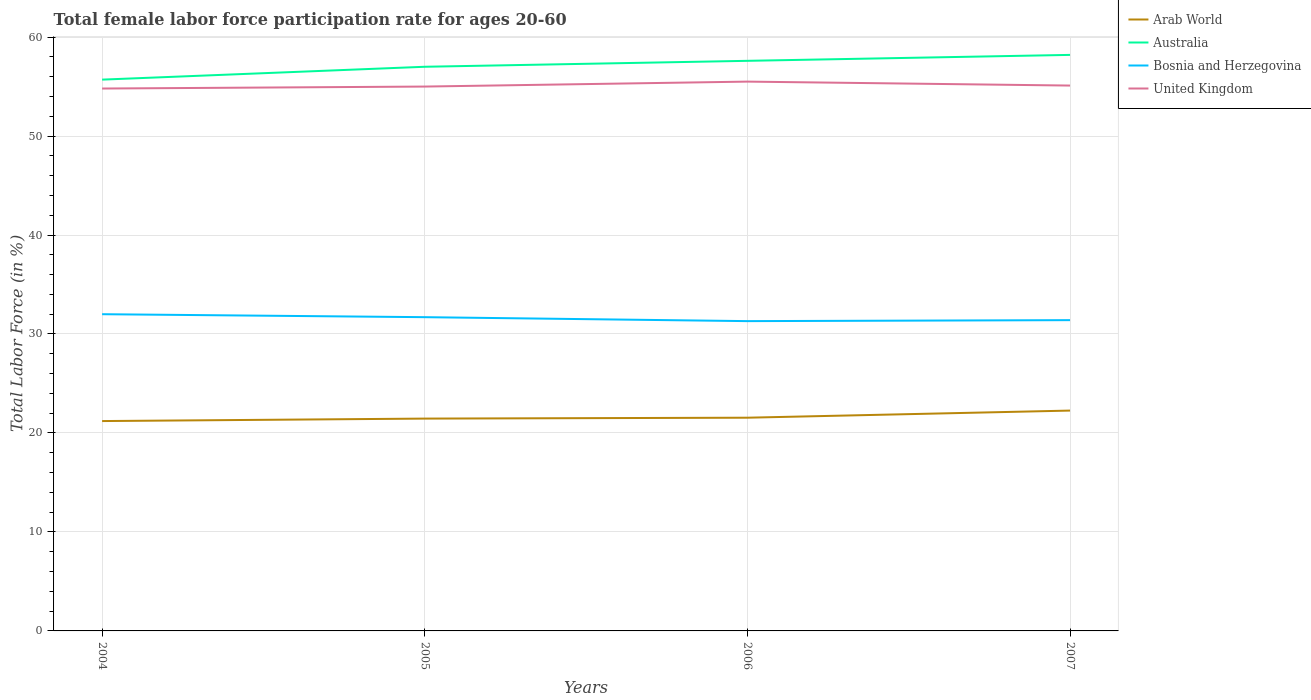How many different coloured lines are there?
Give a very brief answer. 4. Does the line corresponding to Australia intersect with the line corresponding to Bosnia and Herzegovina?
Keep it short and to the point. No. Across all years, what is the maximum female labor force participation rate in United Kingdom?
Your answer should be very brief. 54.8. What is the total female labor force participation rate in Arab World in the graph?
Your answer should be compact. -0.09. What is the difference between the highest and the lowest female labor force participation rate in Bosnia and Herzegovina?
Provide a short and direct response. 2. Is the female labor force participation rate in Australia strictly greater than the female labor force participation rate in Bosnia and Herzegovina over the years?
Provide a short and direct response. No. How many years are there in the graph?
Offer a terse response. 4. Does the graph contain grids?
Give a very brief answer. Yes. Where does the legend appear in the graph?
Ensure brevity in your answer.  Top right. How many legend labels are there?
Make the answer very short. 4. What is the title of the graph?
Your answer should be very brief. Total female labor force participation rate for ages 20-60. Does "Belgium" appear as one of the legend labels in the graph?
Your response must be concise. No. What is the label or title of the X-axis?
Your answer should be compact. Years. What is the label or title of the Y-axis?
Your answer should be very brief. Total Labor Force (in %). What is the Total Labor Force (in %) in Arab World in 2004?
Your response must be concise. 21.2. What is the Total Labor Force (in %) in Australia in 2004?
Ensure brevity in your answer.  55.7. What is the Total Labor Force (in %) of United Kingdom in 2004?
Keep it short and to the point. 54.8. What is the Total Labor Force (in %) in Arab World in 2005?
Offer a terse response. 21.45. What is the Total Labor Force (in %) in Australia in 2005?
Give a very brief answer. 57. What is the Total Labor Force (in %) in Bosnia and Herzegovina in 2005?
Offer a terse response. 31.7. What is the Total Labor Force (in %) of United Kingdom in 2005?
Keep it short and to the point. 55. What is the Total Labor Force (in %) of Arab World in 2006?
Offer a very short reply. 21.54. What is the Total Labor Force (in %) in Australia in 2006?
Keep it short and to the point. 57.6. What is the Total Labor Force (in %) of Bosnia and Herzegovina in 2006?
Provide a short and direct response. 31.3. What is the Total Labor Force (in %) in United Kingdom in 2006?
Your response must be concise. 55.5. What is the Total Labor Force (in %) in Arab World in 2007?
Provide a short and direct response. 22.26. What is the Total Labor Force (in %) in Australia in 2007?
Give a very brief answer. 58.2. What is the Total Labor Force (in %) in Bosnia and Herzegovina in 2007?
Give a very brief answer. 31.4. What is the Total Labor Force (in %) in United Kingdom in 2007?
Give a very brief answer. 55.1. Across all years, what is the maximum Total Labor Force (in %) of Arab World?
Keep it short and to the point. 22.26. Across all years, what is the maximum Total Labor Force (in %) in Australia?
Give a very brief answer. 58.2. Across all years, what is the maximum Total Labor Force (in %) in United Kingdom?
Provide a succinct answer. 55.5. Across all years, what is the minimum Total Labor Force (in %) of Arab World?
Your answer should be compact. 21.2. Across all years, what is the minimum Total Labor Force (in %) of Australia?
Make the answer very short. 55.7. Across all years, what is the minimum Total Labor Force (in %) of Bosnia and Herzegovina?
Your answer should be very brief. 31.3. Across all years, what is the minimum Total Labor Force (in %) in United Kingdom?
Make the answer very short. 54.8. What is the total Total Labor Force (in %) of Arab World in the graph?
Ensure brevity in your answer.  86.46. What is the total Total Labor Force (in %) of Australia in the graph?
Make the answer very short. 228.5. What is the total Total Labor Force (in %) in Bosnia and Herzegovina in the graph?
Make the answer very short. 126.4. What is the total Total Labor Force (in %) in United Kingdom in the graph?
Offer a very short reply. 220.4. What is the difference between the Total Labor Force (in %) in Arab World in 2004 and that in 2005?
Ensure brevity in your answer.  -0.25. What is the difference between the Total Labor Force (in %) of Arab World in 2004 and that in 2006?
Your answer should be very brief. -0.34. What is the difference between the Total Labor Force (in %) of Bosnia and Herzegovina in 2004 and that in 2006?
Ensure brevity in your answer.  0.7. What is the difference between the Total Labor Force (in %) of Arab World in 2004 and that in 2007?
Keep it short and to the point. -1.06. What is the difference between the Total Labor Force (in %) of United Kingdom in 2004 and that in 2007?
Make the answer very short. -0.3. What is the difference between the Total Labor Force (in %) of Arab World in 2005 and that in 2006?
Your response must be concise. -0.09. What is the difference between the Total Labor Force (in %) of Arab World in 2005 and that in 2007?
Ensure brevity in your answer.  -0.81. What is the difference between the Total Labor Force (in %) of Australia in 2005 and that in 2007?
Offer a very short reply. -1.2. What is the difference between the Total Labor Force (in %) of Arab World in 2006 and that in 2007?
Your answer should be compact. -0.72. What is the difference between the Total Labor Force (in %) of United Kingdom in 2006 and that in 2007?
Your answer should be very brief. 0.4. What is the difference between the Total Labor Force (in %) of Arab World in 2004 and the Total Labor Force (in %) of Australia in 2005?
Your answer should be very brief. -35.8. What is the difference between the Total Labor Force (in %) in Arab World in 2004 and the Total Labor Force (in %) in Bosnia and Herzegovina in 2005?
Offer a terse response. -10.5. What is the difference between the Total Labor Force (in %) of Arab World in 2004 and the Total Labor Force (in %) of United Kingdom in 2005?
Provide a short and direct response. -33.8. What is the difference between the Total Labor Force (in %) of Australia in 2004 and the Total Labor Force (in %) of Bosnia and Herzegovina in 2005?
Provide a short and direct response. 24. What is the difference between the Total Labor Force (in %) of Australia in 2004 and the Total Labor Force (in %) of United Kingdom in 2005?
Give a very brief answer. 0.7. What is the difference between the Total Labor Force (in %) of Arab World in 2004 and the Total Labor Force (in %) of Australia in 2006?
Your answer should be very brief. -36.4. What is the difference between the Total Labor Force (in %) of Arab World in 2004 and the Total Labor Force (in %) of Bosnia and Herzegovina in 2006?
Your answer should be very brief. -10.1. What is the difference between the Total Labor Force (in %) of Arab World in 2004 and the Total Labor Force (in %) of United Kingdom in 2006?
Offer a very short reply. -34.3. What is the difference between the Total Labor Force (in %) in Australia in 2004 and the Total Labor Force (in %) in Bosnia and Herzegovina in 2006?
Offer a terse response. 24.4. What is the difference between the Total Labor Force (in %) of Australia in 2004 and the Total Labor Force (in %) of United Kingdom in 2006?
Your response must be concise. 0.2. What is the difference between the Total Labor Force (in %) in Bosnia and Herzegovina in 2004 and the Total Labor Force (in %) in United Kingdom in 2006?
Your answer should be very brief. -23.5. What is the difference between the Total Labor Force (in %) in Arab World in 2004 and the Total Labor Force (in %) in Australia in 2007?
Your response must be concise. -37. What is the difference between the Total Labor Force (in %) in Arab World in 2004 and the Total Labor Force (in %) in Bosnia and Herzegovina in 2007?
Keep it short and to the point. -10.2. What is the difference between the Total Labor Force (in %) of Arab World in 2004 and the Total Labor Force (in %) of United Kingdom in 2007?
Give a very brief answer. -33.9. What is the difference between the Total Labor Force (in %) of Australia in 2004 and the Total Labor Force (in %) of Bosnia and Herzegovina in 2007?
Your answer should be compact. 24.3. What is the difference between the Total Labor Force (in %) of Bosnia and Herzegovina in 2004 and the Total Labor Force (in %) of United Kingdom in 2007?
Provide a succinct answer. -23.1. What is the difference between the Total Labor Force (in %) in Arab World in 2005 and the Total Labor Force (in %) in Australia in 2006?
Keep it short and to the point. -36.15. What is the difference between the Total Labor Force (in %) in Arab World in 2005 and the Total Labor Force (in %) in Bosnia and Herzegovina in 2006?
Your answer should be compact. -9.85. What is the difference between the Total Labor Force (in %) of Arab World in 2005 and the Total Labor Force (in %) of United Kingdom in 2006?
Your answer should be compact. -34.05. What is the difference between the Total Labor Force (in %) in Australia in 2005 and the Total Labor Force (in %) in Bosnia and Herzegovina in 2006?
Keep it short and to the point. 25.7. What is the difference between the Total Labor Force (in %) in Bosnia and Herzegovina in 2005 and the Total Labor Force (in %) in United Kingdom in 2006?
Your response must be concise. -23.8. What is the difference between the Total Labor Force (in %) of Arab World in 2005 and the Total Labor Force (in %) of Australia in 2007?
Keep it short and to the point. -36.75. What is the difference between the Total Labor Force (in %) of Arab World in 2005 and the Total Labor Force (in %) of Bosnia and Herzegovina in 2007?
Give a very brief answer. -9.95. What is the difference between the Total Labor Force (in %) of Arab World in 2005 and the Total Labor Force (in %) of United Kingdom in 2007?
Your response must be concise. -33.65. What is the difference between the Total Labor Force (in %) in Australia in 2005 and the Total Labor Force (in %) in Bosnia and Herzegovina in 2007?
Offer a very short reply. 25.6. What is the difference between the Total Labor Force (in %) of Australia in 2005 and the Total Labor Force (in %) of United Kingdom in 2007?
Offer a terse response. 1.9. What is the difference between the Total Labor Force (in %) of Bosnia and Herzegovina in 2005 and the Total Labor Force (in %) of United Kingdom in 2007?
Your answer should be compact. -23.4. What is the difference between the Total Labor Force (in %) of Arab World in 2006 and the Total Labor Force (in %) of Australia in 2007?
Keep it short and to the point. -36.66. What is the difference between the Total Labor Force (in %) of Arab World in 2006 and the Total Labor Force (in %) of Bosnia and Herzegovina in 2007?
Your answer should be very brief. -9.86. What is the difference between the Total Labor Force (in %) in Arab World in 2006 and the Total Labor Force (in %) in United Kingdom in 2007?
Your response must be concise. -33.56. What is the difference between the Total Labor Force (in %) of Australia in 2006 and the Total Labor Force (in %) of Bosnia and Herzegovina in 2007?
Your answer should be compact. 26.2. What is the difference between the Total Labor Force (in %) in Australia in 2006 and the Total Labor Force (in %) in United Kingdom in 2007?
Ensure brevity in your answer.  2.5. What is the difference between the Total Labor Force (in %) in Bosnia and Herzegovina in 2006 and the Total Labor Force (in %) in United Kingdom in 2007?
Your answer should be very brief. -23.8. What is the average Total Labor Force (in %) in Arab World per year?
Your answer should be very brief. 21.62. What is the average Total Labor Force (in %) in Australia per year?
Keep it short and to the point. 57.12. What is the average Total Labor Force (in %) of Bosnia and Herzegovina per year?
Provide a succinct answer. 31.6. What is the average Total Labor Force (in %) of United Kingdom per year?
Ensure brevity in your answer.  55.1. In the year 2004, what is the difference between the Total Labor Force (in %) of Arab World and Total Labor Force (in %) of Australia?
Provide a succinct answer. -34.5. In the year 2004, what is the difference between the Total Labor Force (in %) of Arab World and Total Labor Force (in %) of Bosnia and Herzegovina?
Provide a succinct answer. -10.8. In the year 2004, what is the difference between the Total Labor Force (in %) in Arab World and Total Labor Force (in %) in United Kingdom?
Keep it short and to the point. -33.6. In the year 2004, what is the difference between the Total Labor Force (in %) of Australia and Total Labor Force (in %) of Bosnia and Herzegovina?
Offer a terse response. 23.7. In the year 2004, what is the difference between the Total Labor Force (in %) in Bosnia and Herzegovina and Total Labor Force (in %) in United Kingdom?
Your answer should be very brief. -22.8. In the year 2005, what is the difference between the Total Labor Force (in %) in Arab World and Total Labor Force (in %) in Australia?
Your answer should be compact. -35.55. In the year 2005, what is the difference between the Total Labor Force (in %) in Arab World and Total Labor Force (in %) in Bosnia and Herzegovina?
Offer a very short reply. -10.25. In the year 2005, what is the difference between the Total Labor Force (in %) in Arab World and Total Labor Force (in %) in United Kingdom?
Your answer should be compact. -33.55. In the year 2005, what is the difference between the Total Labor Force (in %) of Australia and Total Labor Force (in %) of Bosnia and Herzegovina?
Give a very brief answer. 25.3. In the year 2005, what is the difference between the Total Labor Force (in %) of Australia and Total Labor Force (in %) of United Kingdom?
Your answer should be very brief. 2. In the year 2005, what is the difference between the Total Labor Force (in %) of Bosnia and Herzegovina and Total Labor Force (in %) of United Kingdom?
Your answer should be very brief. -23.3. In the year 2006, what is the difference between the Total Labor Force (in %) of Arab World and Total Labor Force (in %) of Australia?
Your answer should be compact. -36.06. In the year 2006, what is the difference between the Total Labor Force (in %) in Arab World and Total Labor Force (in %) in Bosnia and Herzegovina?
Provide a succinct answer. -9.76. In the year 2006, what is the difference between the Total Labor Force (in %) of Arab World and Total Labor Force (in %) of United Kingdom?
Keep it short and to the point. -33.96. In the year 2006, what is the difference between the Total Labor Force (in %) of Australia and Total Labor Force (in %) of Bosnia and Herzegovina?
Offer a terse response. 26.3. In the year 2006, what is the difference between the Total Labor Force (in %) of Australia and Total Labor Force (in %) of United Kingdom?
Your answer should be very brief. 2.1. In the year 2006, what is the difference between the Total Labor Force (in %) of Bosnia and Herzegovina and Total Labor Force (in %) of United Kingdom?
Your response must be concise. -24.2. In the year 2007, what is the difference between the Total Labor Force (in %) in Arab World and Total Labor Force (in %) in Australia?
Your answer should be compact. -35.94. In the year 2007, what is the difference between the Total Labor Force (in %) of Arab World and Total Labor Force (in %) of Bosnia and Herzegovina?
Your answer should be compact. -9.14. In the year 2007, what is the difference between the Total Labor Force (in %) of Arab World and Total Labor Force (in %) of United Kingdom?
Your answer should be compact. -32.84. In the year 2007, what is the difference between the Total Labor Force (in %) in Australia and Total Labor Force (in %) in Bosnia and Herzegovina?
Your answer should be compact. 26.8. In the year 2007, what is the difference between the Total Labor Force (in %) of Bosnia and Herzegovina and Total Labor Force (in %) of United Kingdom?
Give a very brief answer. -23.7. What is the ratio of the Total Labor Force (in %) in Arab World in 2004 to that in 2005?
Keep it short and to the point. 0.99. What is the ratio of the Total Labor Force (in %) in Australia in 2004 to that in 2005?
Ensure brevity in your answer.  0.98. What is the ratio of the Total Labor Force (in %) in Bosnia and Herzegovina in 2004 to that in 2005?
Give a very brief answer. 1.01. What is the ratio of the Total Labor Force (in %) of Arab World in 2004 to that in 2006?
Your answer should be very brief. 0.98. What is the ratio of the Total Labor Force (in %) in Australia in 2004 to that in 2006?
Provide a short and direct response. 0.97. What is the ratio of the Total Labor Force (in %) in Bosnia and Herzegovina in 2004 to that in 2006?
Provide a short and direct response. 1.02. What is the ratio of the Total Labor Force (in %) of United Kingdom in 2004 to that in 2006?
Your response must be concise. 0.99. What is the ratio of the Total Labor Force (in %) in Australia in 2004 to that in 2007?
Make the answer very short. 0.96. What is the ratio of the Total Labor Force (in %) of Bosnia and Herzegovina in 2004 to that in 2007?
Make the answer very short. 1.02. What is the ratio of the Total Labor Force (in %) in United Kingdom in 2004 to that in 2007?
Ensure brevity in your answer.  0.99. What is the ratio of the Total Labor Force (in %) in Bosnia and Herzegovina in 2005 to that in 2006?
Offer a very short reply. 1.01. What is the ratio of the Total Labor Force (in %) in United Kingdom in 2005 to that in 2006?
Make the answer very short. 0.99. What is the ratio of the Total Labor Force (in %) of Arab World in 2005 to that in 2007?
Your response must be concise. 0.96. What is the ratio of the Total Labor Force (in %) of Australia in 2005 to that in 2007?
Offer a very short reply. 0.98. What is the ratio of the Total Labor Force (in %) of Bosnia and Herzegovina in 2005 to that in 2007?
Provide a succinct answer. 1.01. What is the ratio of the Total Labor Force (in %) of United Kingdom in 2005 to that in 2007?
Ensure brevity in your answer.  1. What is the ratio of the Total Labor Force (in %) in Arab World in 2006 to that in 2007?
Your response must be concise. 0.97. What is the ratio of the Total Labor Force (in %) of Australia in 2006 to that in 2007?
Ensure brevity in your answer.  0.99. What is the ratio of the Total Labor Force (in %) of Bosnia and Herzegovina in 2006 to that in 2007?
Your answer should be very brief. 1. What is the ratio of the Total Labor Force (in %) of United Kingdom in 2006 to that in 2007?
Provide a short and direct response. 1.01. What is the difference between the highest and the second highest Total Labor Force (in %) of Arab World?
Provide a succinct answer. 0.72. What is the difference between the highest and the second highest Total Labor Force (in %) in Bosnia and Herzegovina?
Provide a succinct answer. 0.3. What is the difference between the highest and the lowest Total Labor Force (in %) of Arab World?
Provide a short and direct response. 1.06. 